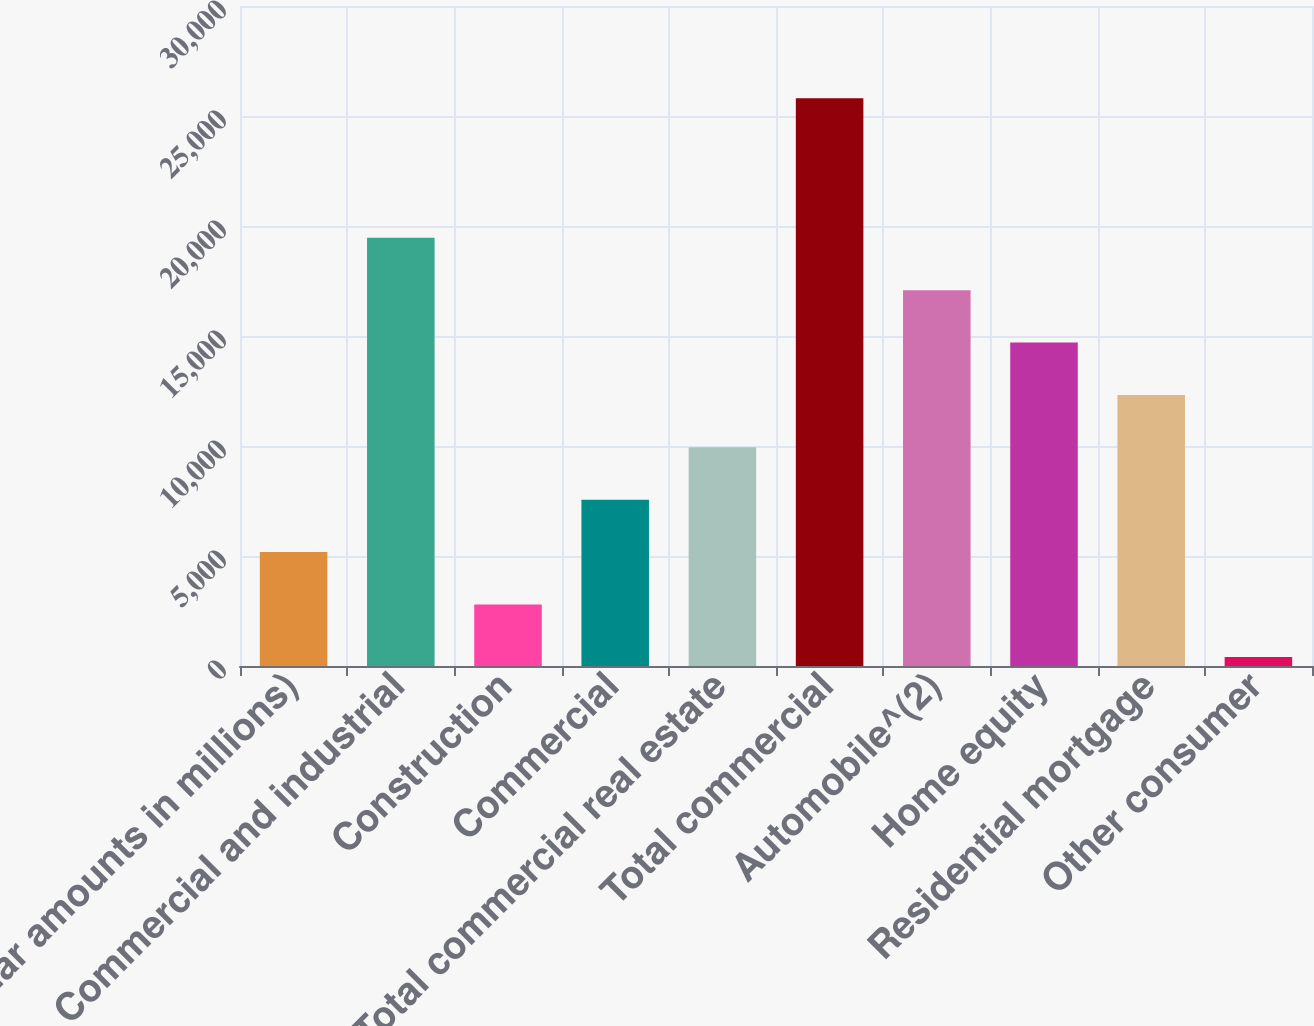Convert chart. <chart><loc_0><loc_0><loc_500><loc_500><bar_chart><fcel>(dollar amounts in millions)<fcel>Commercial and industrial<fcel>Construction<fcel>Commercial<fcel>Total commercial real estate<fcel>Total commercial<fcel>Automobile^(2)<fcel>Home equity<fcel>Residential mortgage<fcel>Other consumer<nl><fcel>5177.2<fcel>19466.8<fcel>2795.6<fcel>7558.8<fcel>9940.4<fcel>25807.6<fcel>17085.2<fcel>14703.6<fcel>12322<fcel>414<nl></chart> 